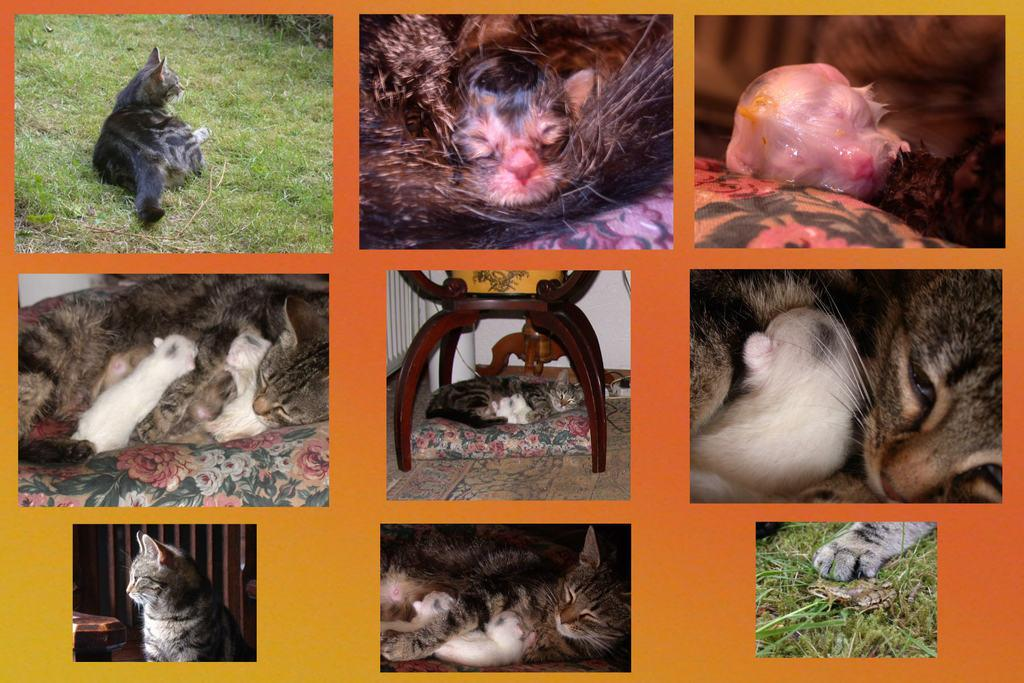What is the main subject of the image? The main subject of the image is a collage of different animals. Can you describe the types of animals featured in the collage? Unfortunately, the provided facts do not specify the types of animals in the collage. However, the image is a collage of different animals. What is the daughter's favorite animal in the collage? There is no daughter present in the image, as the main subject is a collage of different animals. 